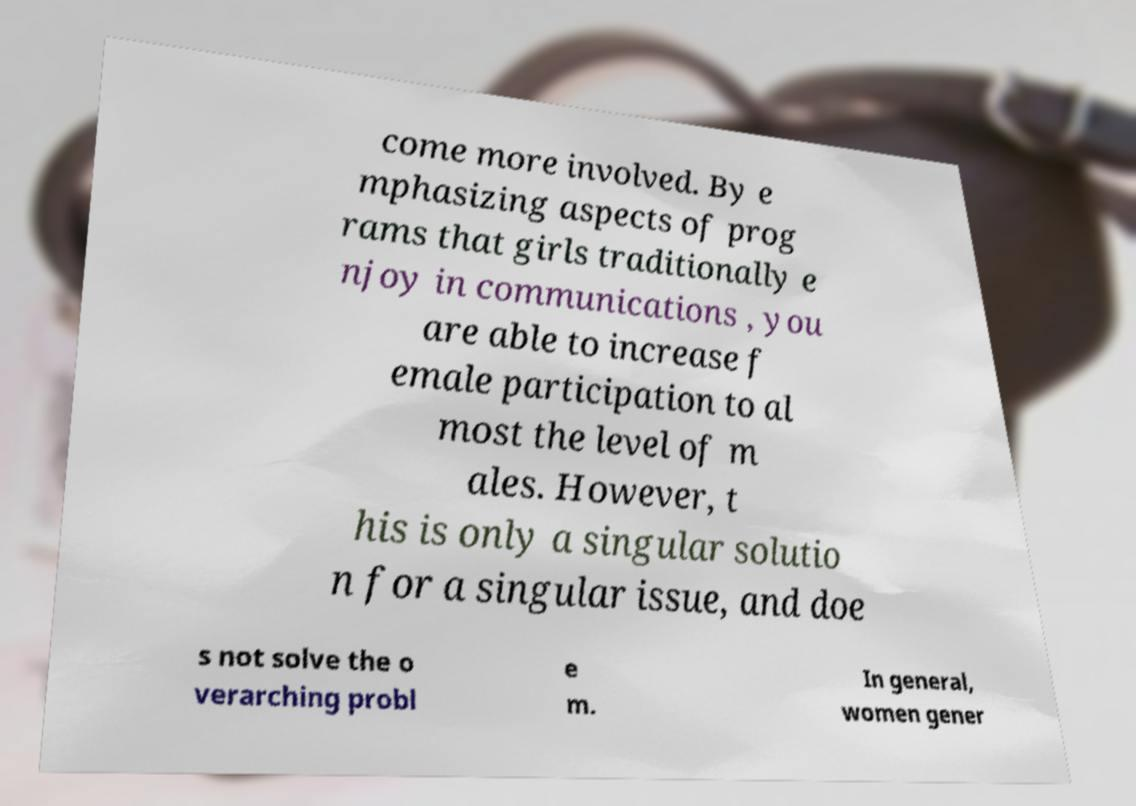Could you extract and type out the text from this image? come more involved. By e mphasizing aspects of prog rams that girls traditionally e njoy in communications , you are able to increase f emale participation to al most the level of m ales. However, t his is only a singular solutio n for a singular issue, and doe s not solve the o verarching probl e m. In general, women gener 